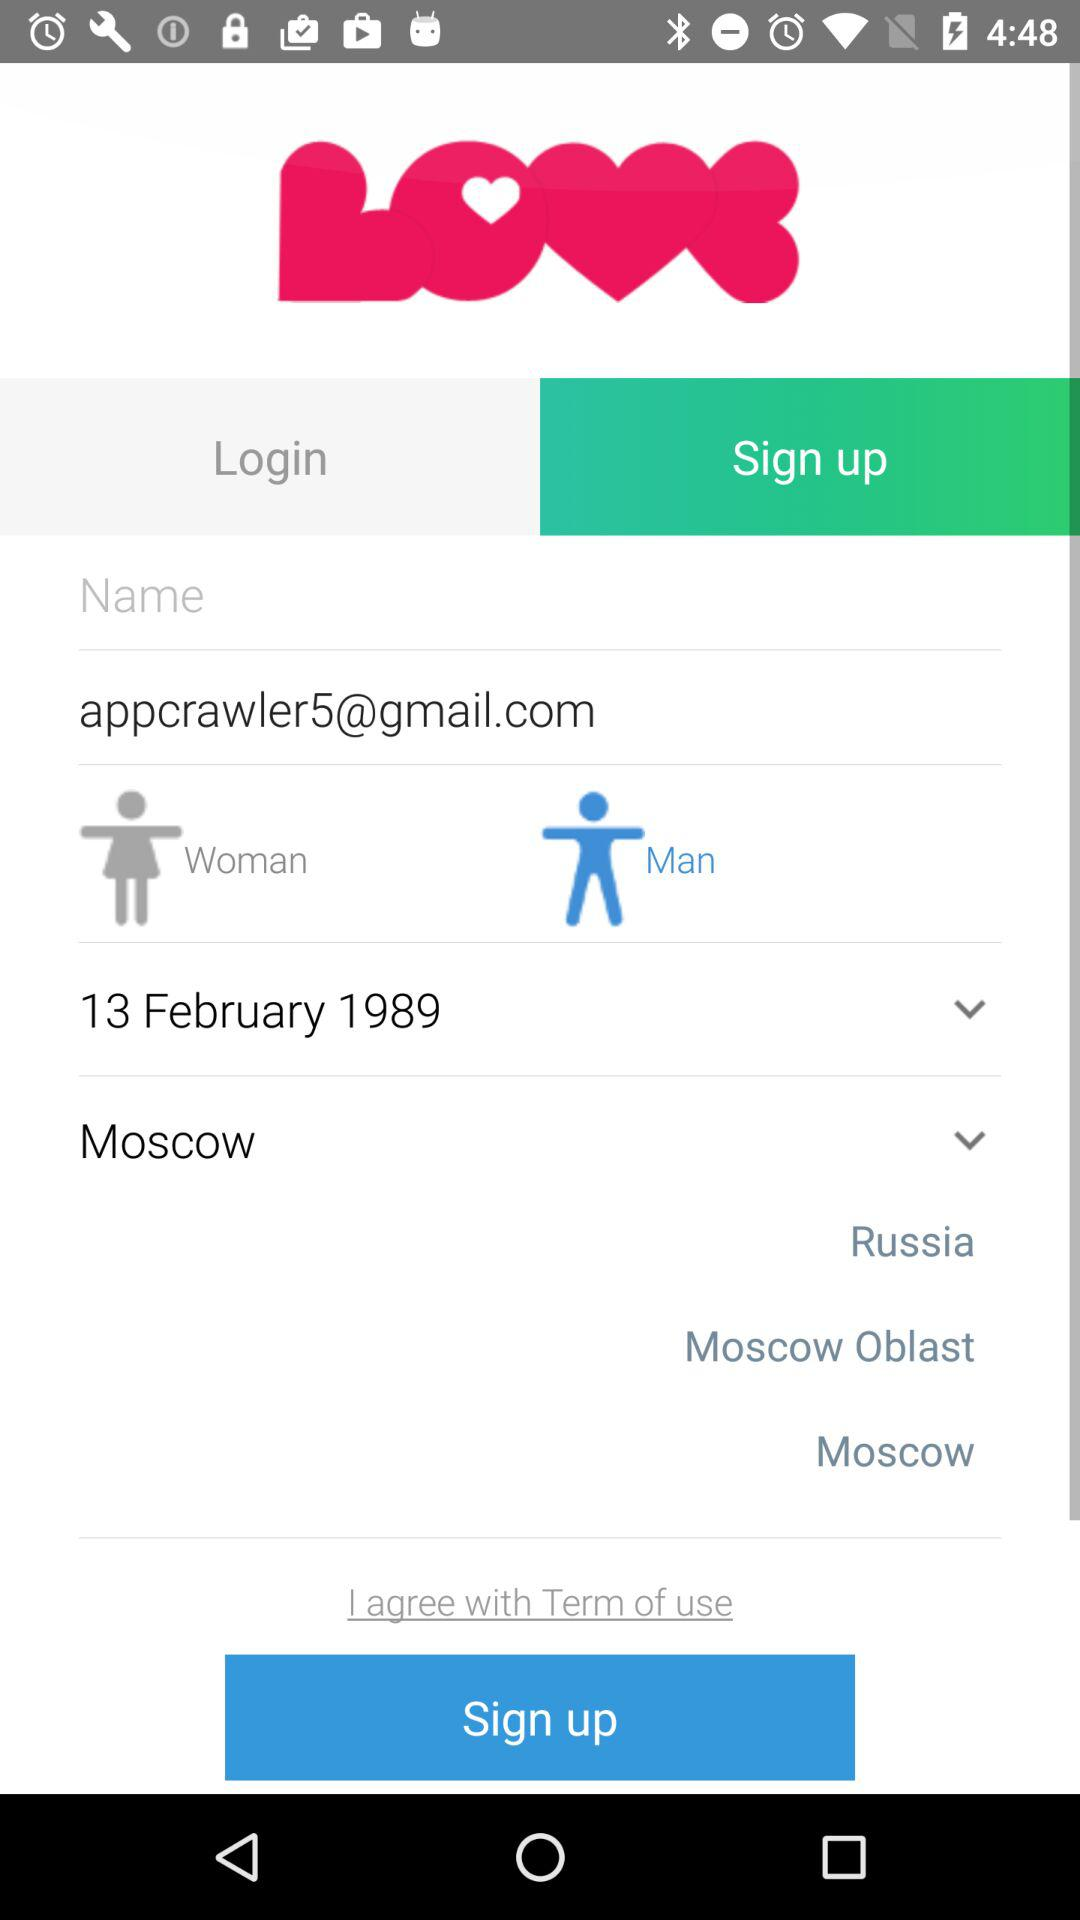What email address is used? The email address used is appcrawler5@gmail.com. 